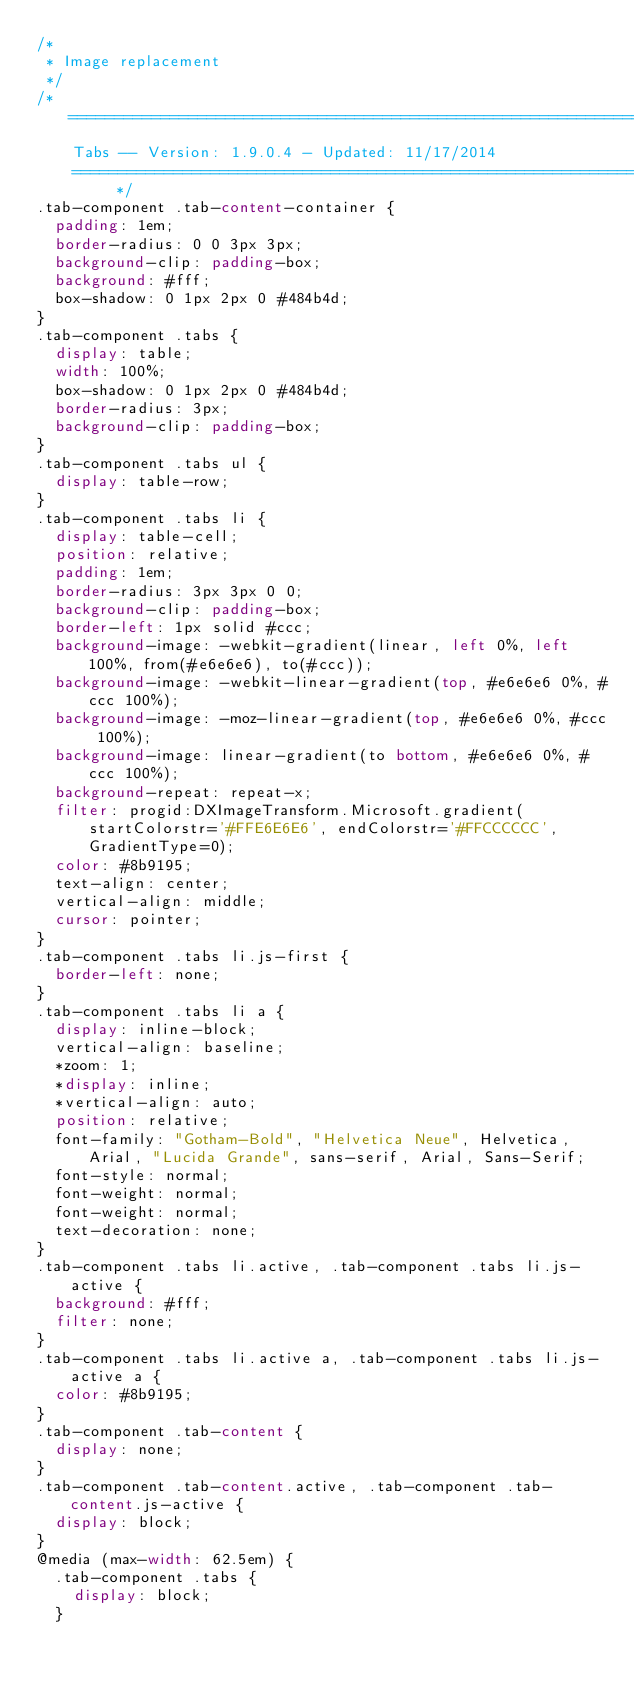<code> <loc_0><loc_0><loc_500><loc_500><_CSS_>/*
 * Image replacement
 */
/* ==========================================================================
    Tabs -- Version: 1.9.0.4 - Updated: 11/17/2014
    ========================================================================== */
.tab-component .tab-content-container {
  padding: 1em;
  border-radius: 0 0 3px 3px;
  background-clip: padding-box;
  background: #fff;
  box-shadow: 0 1px 2px 0 #484b4d;
}
.tab-component .tabs {
  display: table;
  width: 100%;
  box-shadow: 0 1px 2px 0 #484b4d;
  border-radius: 3px;
  background-clip: padding-box;
}
.tab-component .tabs ul {
  display: table-row;
}
.tab-component .tabs li {
  display: table-cell;
  position: relative;
  padding: 1em;
  border-radius: 3px 3px 0 0;
  background-clip: padding-box;
  border-left: 1px solid #ccc;
  background-image: -webkit-gradient(linear, left 0%, left 100%, from(#e6e6e6), to(#ccc));
  background-image: -webkit-linear-gradient(top, #e6e6e6 0%, #ccc 100%);
  background-image: -moz-linear-gradient(top, #e6e6e6 0%, #ccc 100%);
  background-image: linear-gradient(to bottom, #e6e6e6 0%, #ccc 100%);
  background-repeat: repeat-x;
  filter: progid:DXImageTransform.Microsoft.gradient(startColorstr='#FFE6E6E6', endColorstr='#FFCCCCCC', GradientType=0);
  color: #8b9195;
  text-align: center;
  vertical-align: middle;
  cursor: pointer;
}
.tab-component .tabs li.js-first {
  border-left: none;
}
.tab-component .tabs li a {
  display: inline-block;
  vertical-align: baseline;
  *zoom: 1;
  *display: inline;
  *vertical-align: auto;
  position: relative;
  font-family: "Gotham-Bold", "Helvetica Neue", Helvetica, Arial, "Lucida Grande", sans-serif, Arial, Sans-Serif;
  font-style: normal;
  font-weight: normal;
  font-weight: normal;
  text-decoration: none;
}
.tab-component .tabs li.active, .tab-component .tabs li.js-active {
  background: #fff;
  filter: none;
}
.tab-component .tabs li.active a, .tab-component .tabs li.js-active a {
  color: #8b9195;
}
.tab-component .tab-content {
  display: none;
}
.tab-component .tab-content.active, .tab-component .tab-content.js-active {
  display: block;
}
@media (max-width: 62.5em) {
  .tab-component .tabs {
    display: block;
  }</code> 